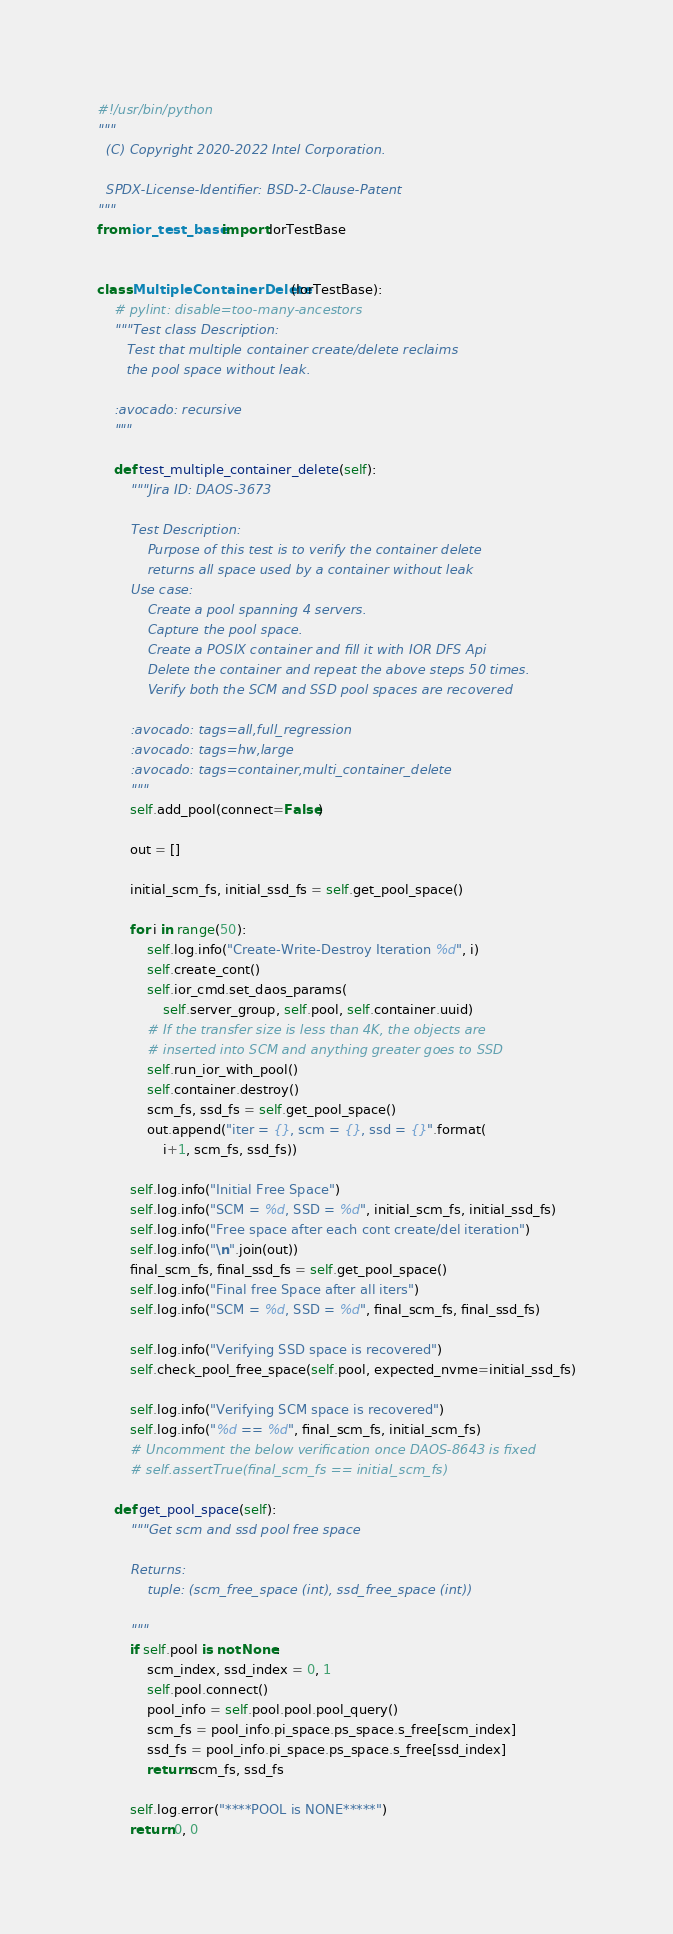<code> <loc_0><loc_0><loc_500><loc_500><_Python_>#!/usr/bin/python
"""
  (C) Copyright 2020-2022 Intel Corporation.

  SPDX-License-Identifier: BSD-2-Clause-Patent
"""
from ior_test_base import IorTestBase


class MultipleContainerDelete(IorTestBase):
    # pylint: disable=too-many-ancestors
    """Test class Description:
       Test that multiple container create/delete reclaims
       the pool space without leak.

    :avocado: recursive
    """

    def test_multiple_container_delete(self):
        """Jira ID: DAOS-3673

        Test Description:
            Purpose of this test is to verify the container delete
            returns all space used by a container without leak
        Use case:
            Create a pool spanning 4 servers.
            Capture the pool space.
            Create a POSIX container and fill it with IOR DFS Api
            Delete the container and repeat the above steps 50 times.
            Verify both the SCM and SSD pool spaces are recovered

        :avocado: tags=all,full_regression
        :avocado: tags=hw,large
        :avocado: tags=container,multi_container_delete
        """
        self.add_pool(connect=False)

        out = []

        initial_scm_fs, initial_ssd_fs = self.get_pool_space()

        for i in range(50):
            self.log.info("Create-Write-Destroy Iteration %d", i)
            self.create_cont()
            self.ior_cmd.set_daos_params(
                self.server_group, self.pool, self.container.uuid)
            # If the transfer size is less than 4K, the objects are
            # inserted into SCM and anything greater goes to SSD
            self.run_ior_with_pool()
            self.container.destroy()
            scm_fs, ssd_fs = self.get_pool_space()
            out.append("iter = {}, scm = {}, ssd = {}".format(
                i+1, scm_fs, ssd_fs))

        self.log.info("Initial Free Space")
        self.log.info("SCM = %d, SSD = %d", initial_scm_fs, initial_ssd_fs)
        self.log.info("Free space after each cont create/del iteration")
        self.log.info("\n".join(out))
        final_scm_fs, final_ssd_fs = self.get_pool_space()
        self.log.info("Final free Space after all iters")
        self.log.info("SCM = %d, SSD = %d", final_scm_fs, final_ssd_fs)

        self.log.info("Verifying SSD space is recovered")
        self.check_pool_free_space(self.pool, expected_nvme=initial_ssd_fs)

        self.log.info("Verifying SCM space is recovered")
        self.log.info("%d == %d", final_scm_fs, initial_scm_fs)
        # Uncomment the below verification once DAOS-8643 is fixed
        # self.assertTrue(final_scm_fs == initial_scm_fs)

    def get_pool_space(self):
        """Get scm and ssd pool free space

        Returns:
            tuple: (scm_free_space (int), ssd_free_space (int))

        """
        if self.pool is not None:
            scm_index, ssd_index = 0, 1
            self.pool.connect()
            pool_info = self.pool.pool.pool_query()
            scm_fs = pool_info.pi_space.ps_space.s_free[scm_index]
            ssd_fs = pool_info.pi_space.ps_space.s_free[ssd_index]
            return scm_fs, ssd_fs

        self.log.error("****POOL is NONE*****")
        return 0, 0
</code> 